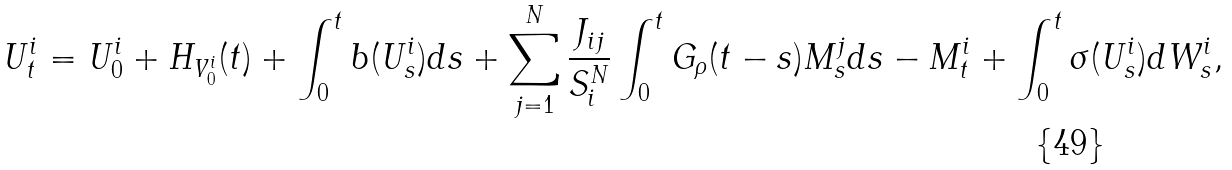Convert formula to latex. <formula><loc_0><loc_0><loc_500><loc_500>U _ { t } ^ { i } = U ^ { i } _ { 0 } + H _ { V _ { 0 } ^ { i } } ( t ) + \int _ { 0 } ^ { t } b ( U _ { s } ^ { i } ) d s + \sum _ { j = 1 } ^ { N } \frac { J _ { i j } } { S ^ { N } _ { i } } \int _ { 0 } ^ { t } { G } _ { \rho } ( t - s ) M _ { s } ^ { j } d s - M ^ { i } _ { t } + \int _ { 0 } ^ { t } \sigma ( U _ { s } ^ { i } ) d W _ { s } ^ { i } ,</formula> 